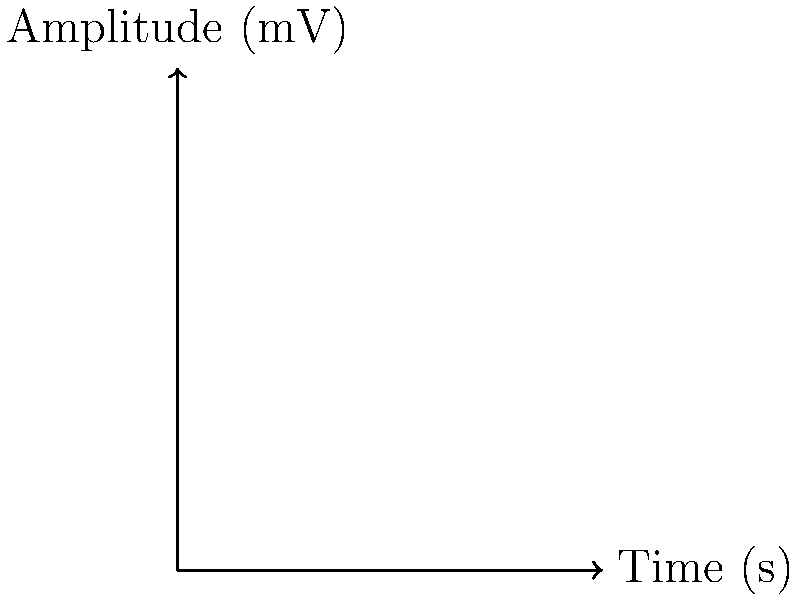As the director of a rural clinic utilizing new technology for patient care, you're analyzing EMG data from two different rehabilitation exercises. The blue waveform represents Exercise A, and the red waveform represents Exercise B. Based on the EMG signal characteristics shown in the graph, which exercise is likely to involve a more sudden, explosive muscle contraction? To determine which exercise involves a more sudden, explosive muscle contraction, we need to analyze the characteristics of both EMG waveforms:

1. Exercise A (Blue waveform):
   - The signal rises more quickly from the baseline.
   - It reaches its peak amplitude earlier (around 4-5 seconds).
   - The overall shape is more peaked and less rounded.

2. Exercise B (Red waveform):
   - The signal rises more gradually from the baseline.
   - It reaches its peak amplitude later (around 5-6 seconds).
   - The overall shape is more rounded and symmetrical.

3. Interpretation:
   - Sudden, explosive muscle contractions typically produce EMG signals with:
     a) Faster rise times
     b) Earlier peak amplitudes
     c) More peaked shapes

4. Comparison:
   - Exercise A's waveform exhibits these characteristics more prominently than Exercise B.

5. Clinical relevance:
   - In a rehabilitation setting, exercises with sudden, explosive contractions might be used for:
     a) Power training
     b) Improving fast-twitch muscle fiber recruitment
     c) Enhancing neuromuscular coordination

Therefore, based on the EMG signal characteristics, Exercise A is more likely to involve a sudden, explosive muscle contraction compared to Exercise B.
Answer: Exercise A 